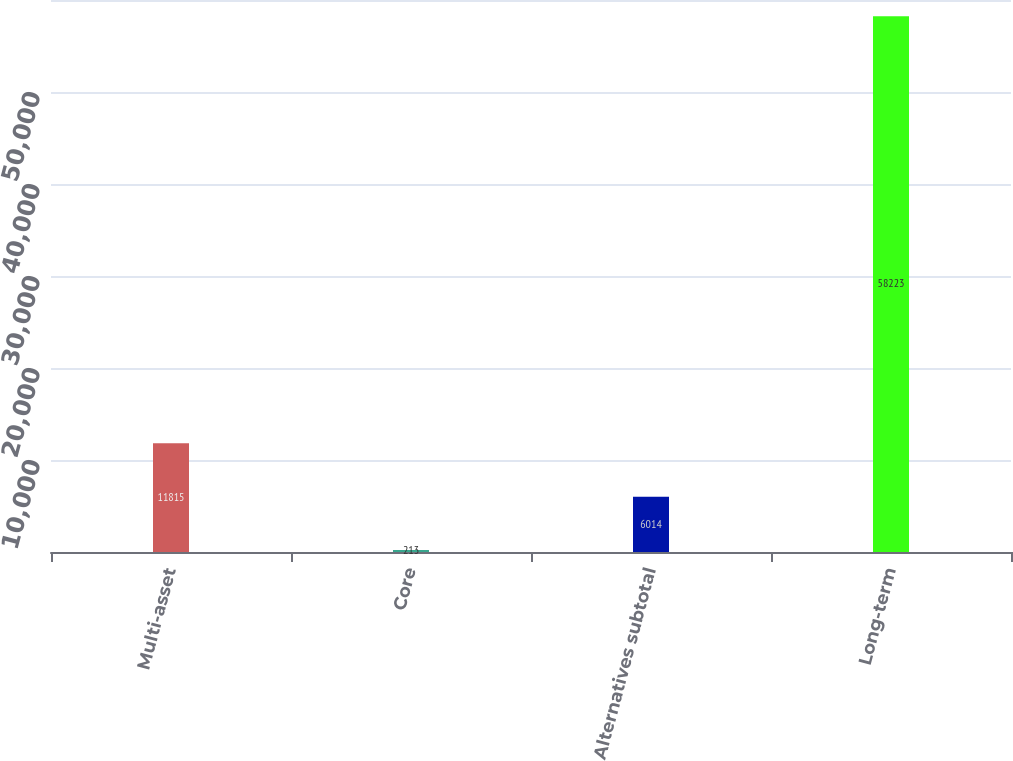Convert chart to OTSL. <chart><loc_0><loc_0><loc_500><loc_500><bar_chart><fcel>Multi-asset<fcel>Core<fcel>Alternatives subtotal<fcel>Long-term<nl><fcel>11815<fcel>213<fcel>6014<fcel>58223<nl></chart> 